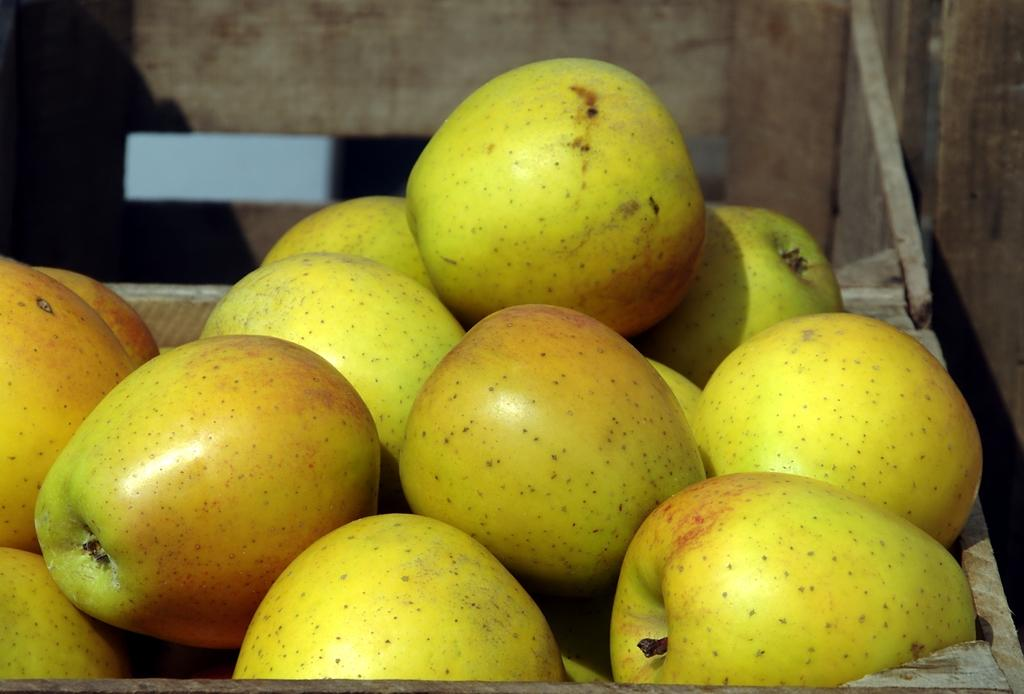What type of fruit is present in the image? There are apples in the image. How are the apples arranged or stored in the image? The apples are present in a container. What type of vegetable is the scarecrow holding in the image? There is no scarecrow or vegetable present in the image; it only features apples in a container. 